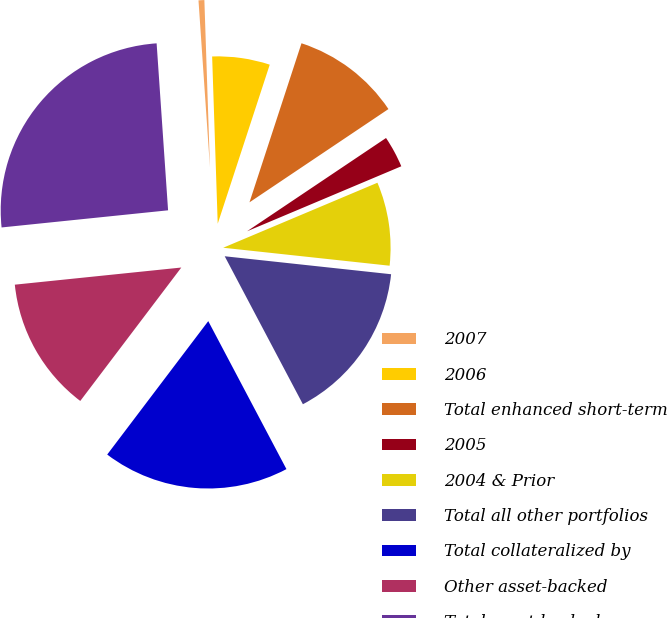Convert chart to OTSL. <chart><loc_0><loc_0><loc_500><loc_500><pie_chart><fcel>2007<fcel>2006<fcel>Total enhanced short-term<fcel>2005<fcel>2004 & Prior<fcel>Total all other portfolios<fcel>Total collateralized by<fcel>Other asset-backed<fcel>Total asset-backed<nl><fcel>0.56%<fcel>5.56%<fcel>10.56%<fcel>3.06%<fcel>8.06%<fcel>15.55%<fcel>18.05%<fcel>13.05%<fcel>25.54%<nl></chart> 